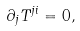Convert formula to latex. <formula><loc_0><loc_0><loc_500><loc_500>\partial _ { j } T ^ { j i } = 0 ,</formula> 